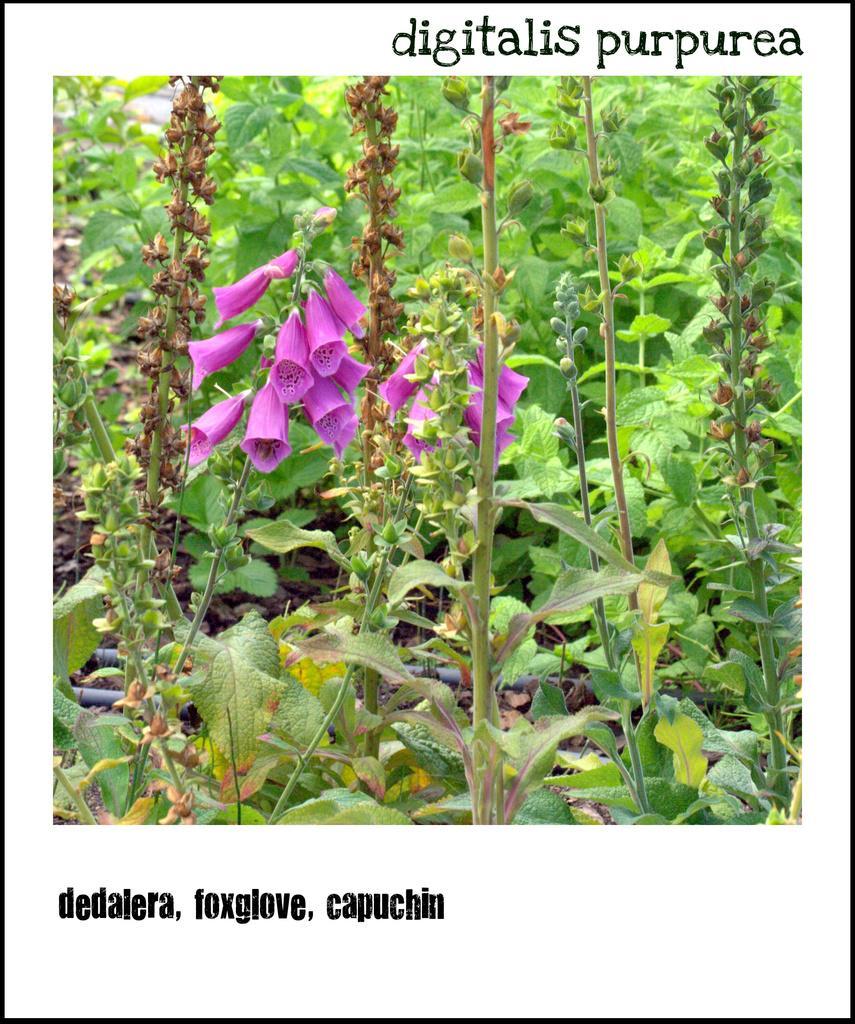Can you describe this image briefly? In this picture we can see a poster, there is a picture of flowers and plants in the middle, we can see some text on the poster. 